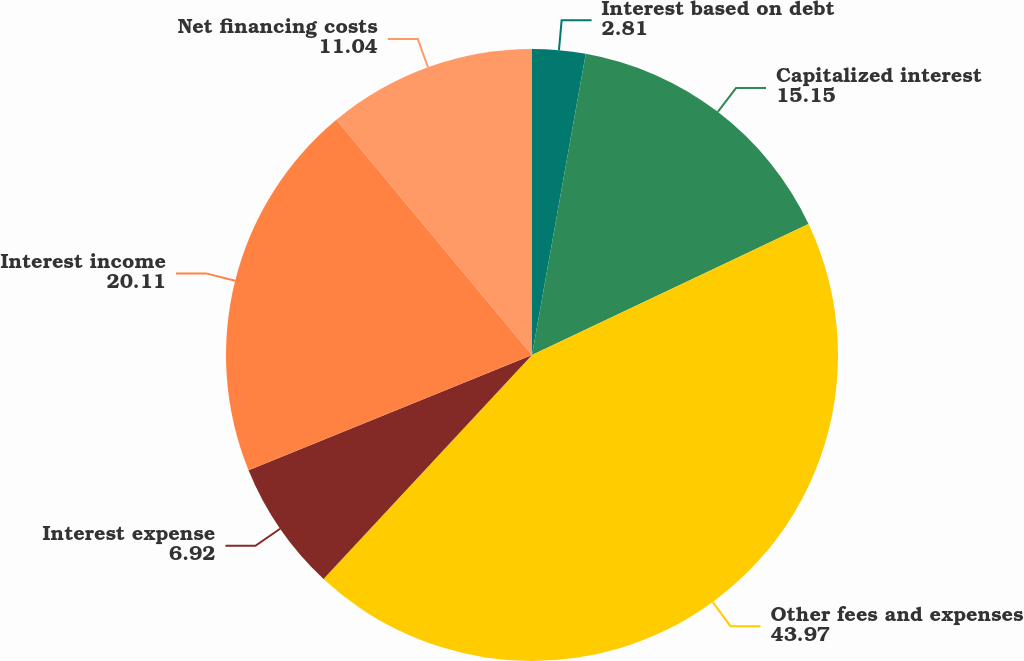Convert chart. <chart><loc_0><loc_0><loc_500><loc_500><pie_chart><fcel>Interest based on debt<fcel>Capitalized interest<fcel>Other fees and expenses<fcel>Interest expense<fcel>Interest income<fcel>Net financing costs<nl><fcel>2.81%<fcel>15.15%<fcel>43.97%<fcel>6.92%<fcel>20.11%<fcel>11.04%<nl></chart> 